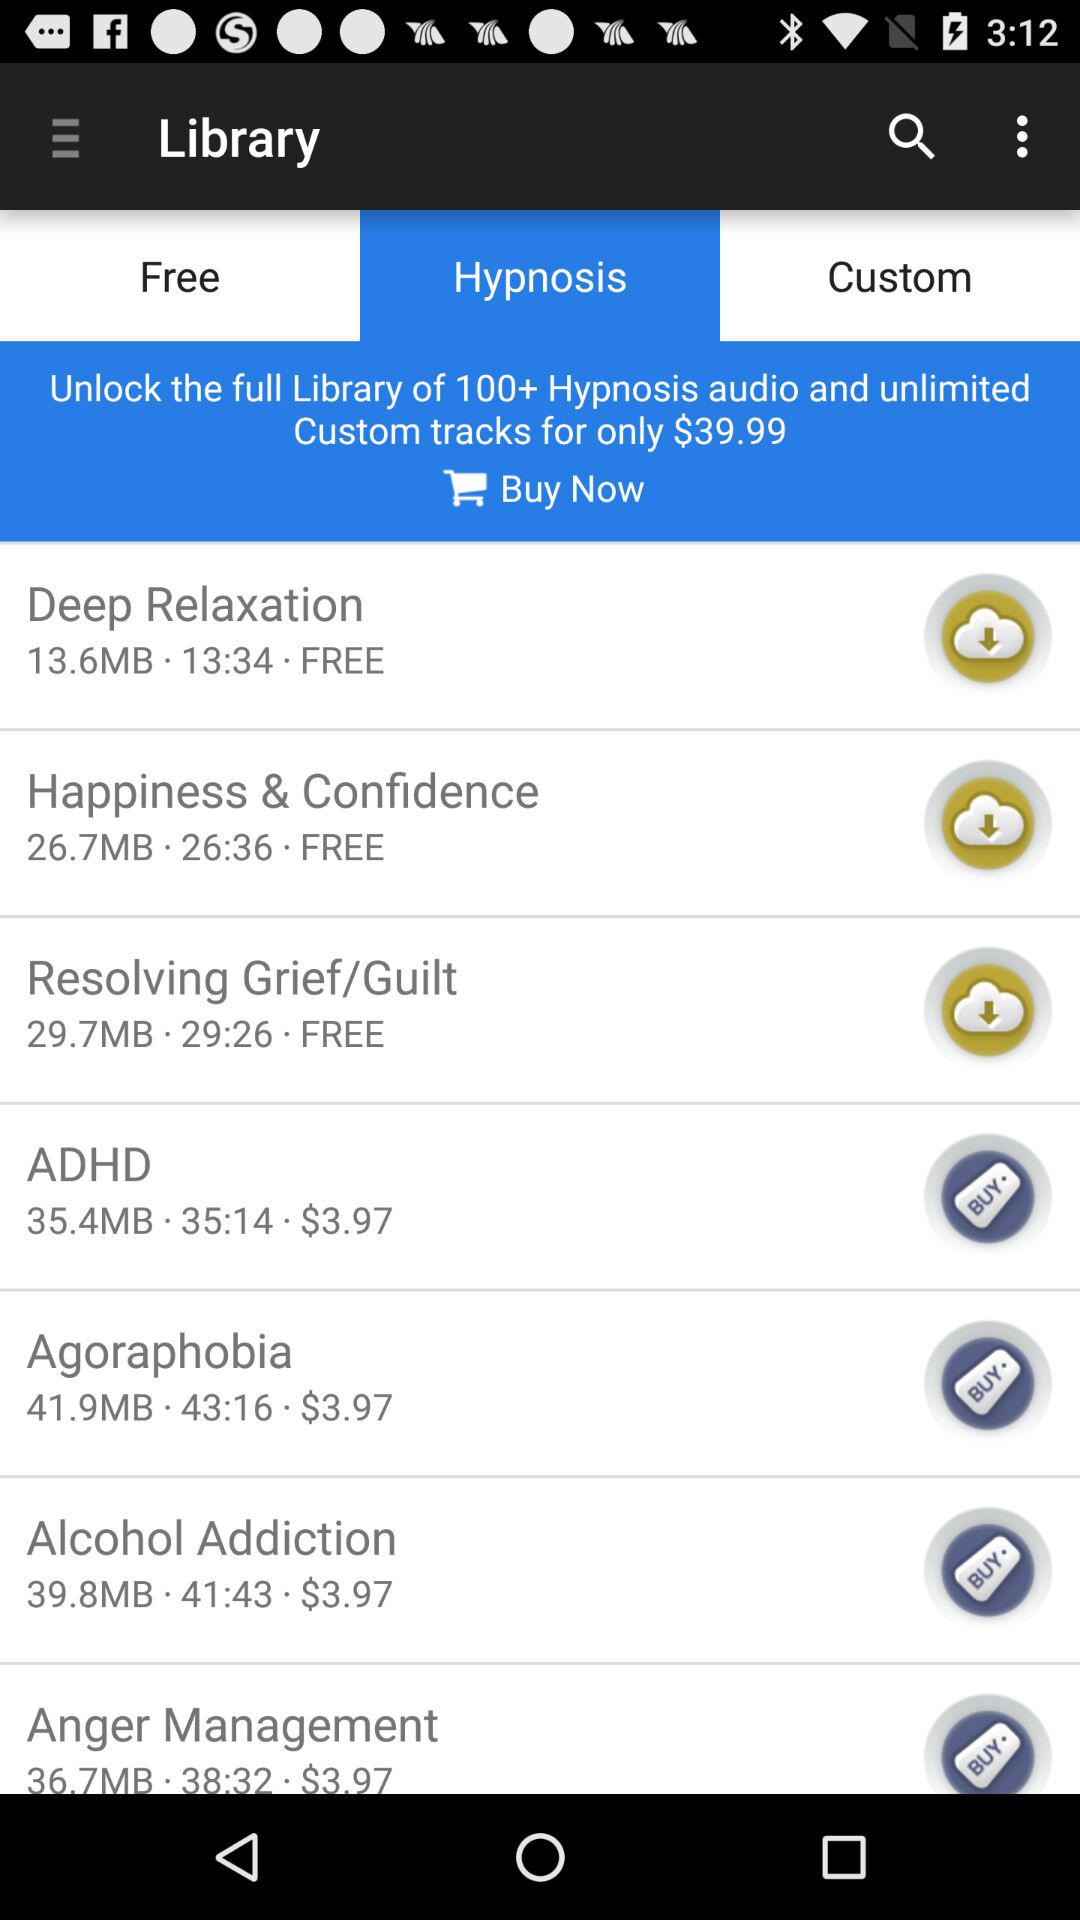How much space is contained by alcohol addiction? Alcohol addiction contains 39.8MB of space. 